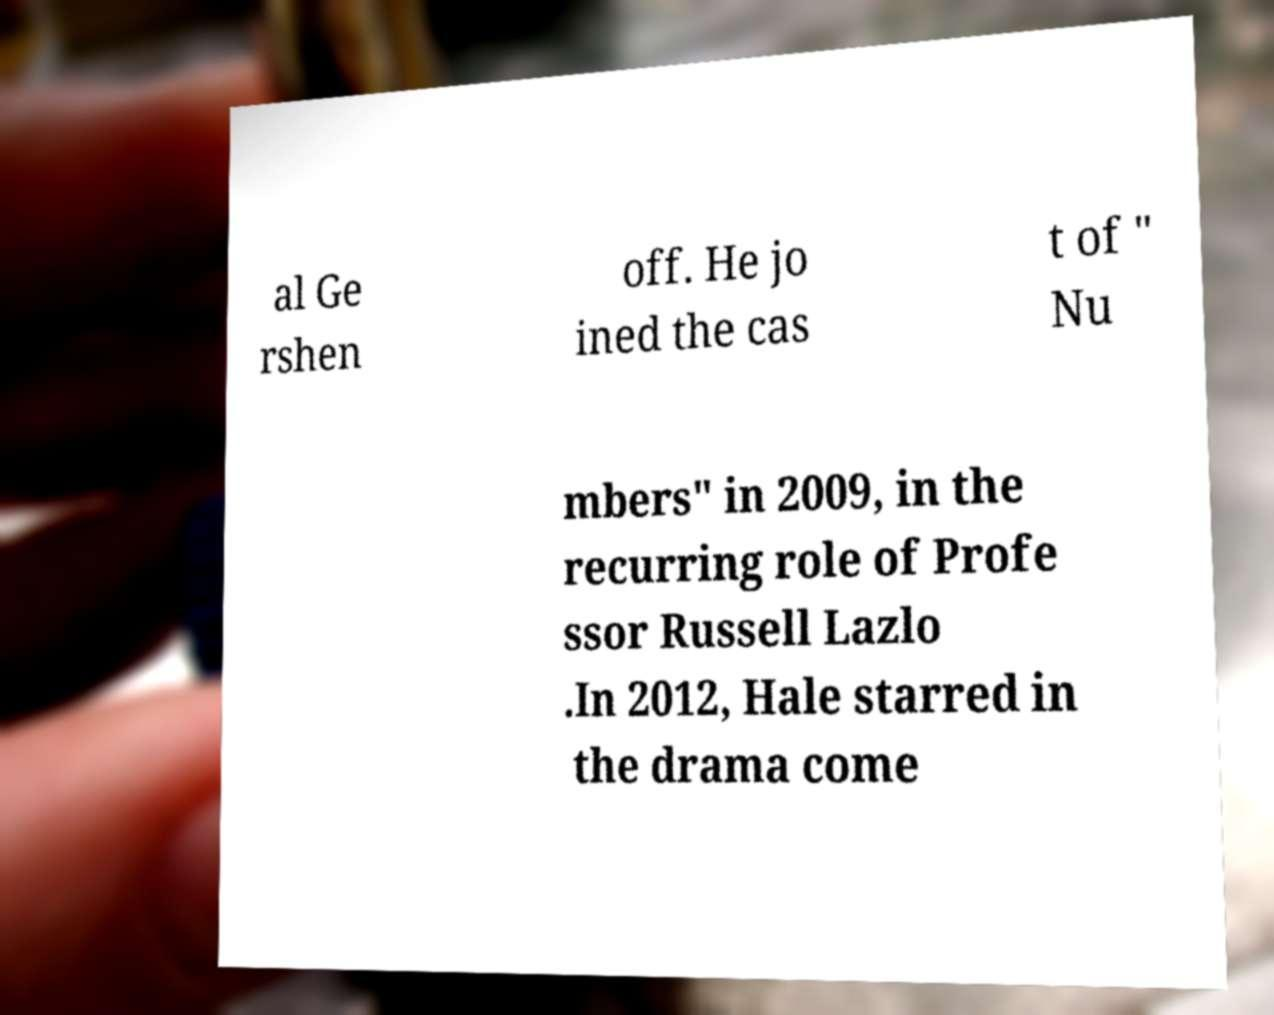What messages or text are displayed in this image? I need them in a readable, typed format. al Ge rshen off. He jo ined the cas t of " Nu mbers" in 2009, in the recurring role of Profe ssor Russell Lazlo .In 2012, Hale starred in the drama come 